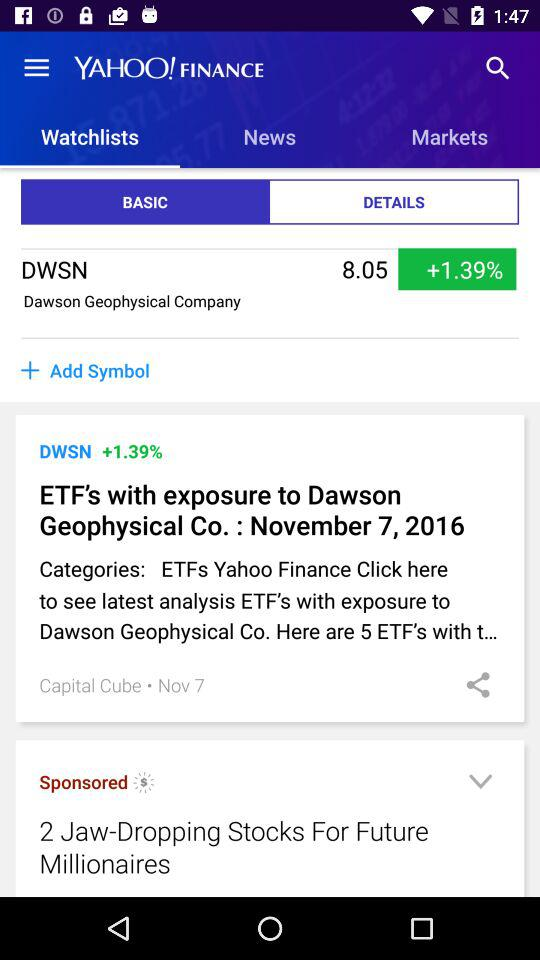What is the percentage increase in the DWSN stock? The increased percentage is 1.39. 